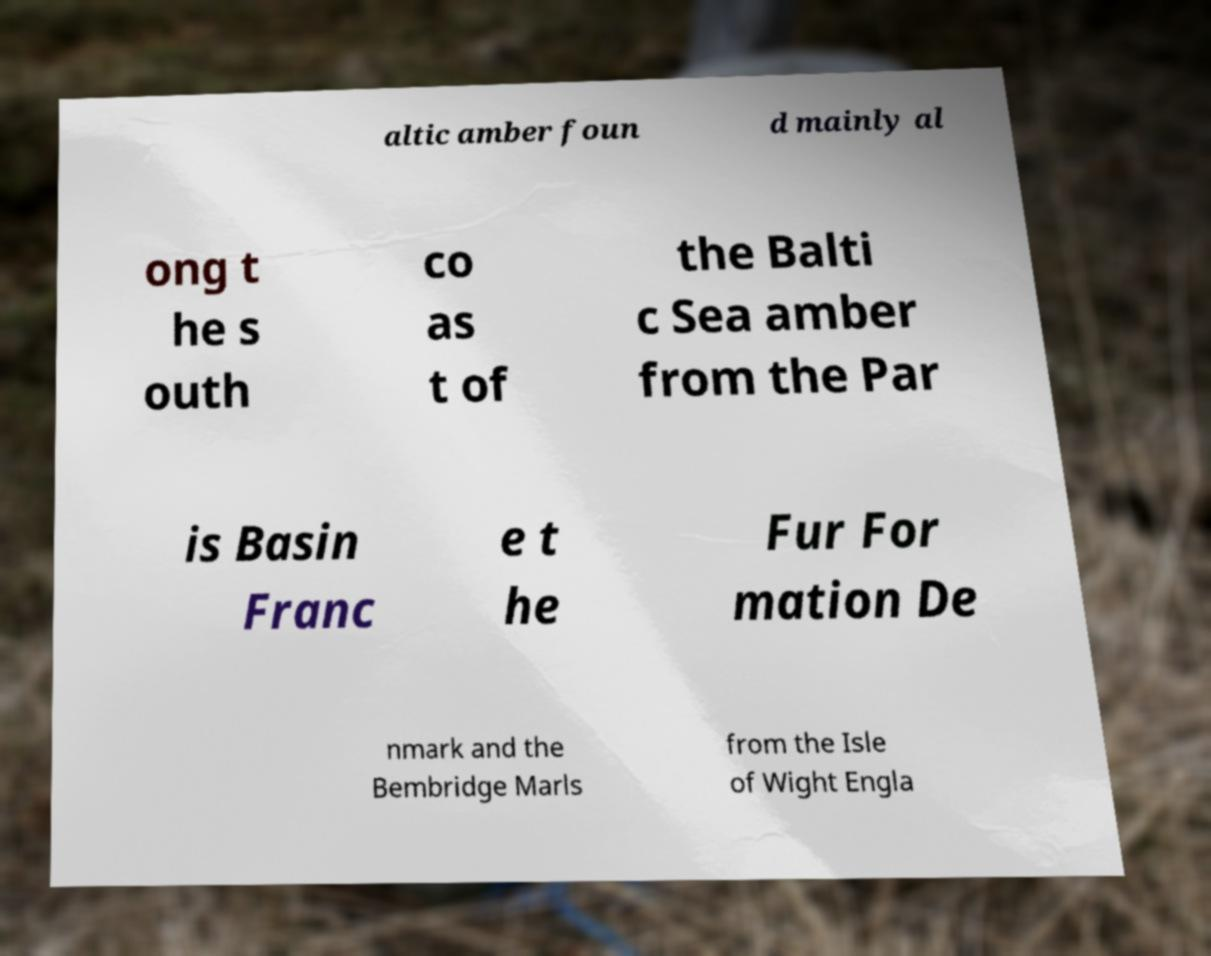For documentation purposes, I need the text within this image transcribed. Could you provide that? altic amber foun d mainly al ong t he s outh co as t of the Balti c Sea amber from the Par is Basin Franc e t he Fur For mation De nmark and the Bembridge Marls from the Isle of Wight Engla 